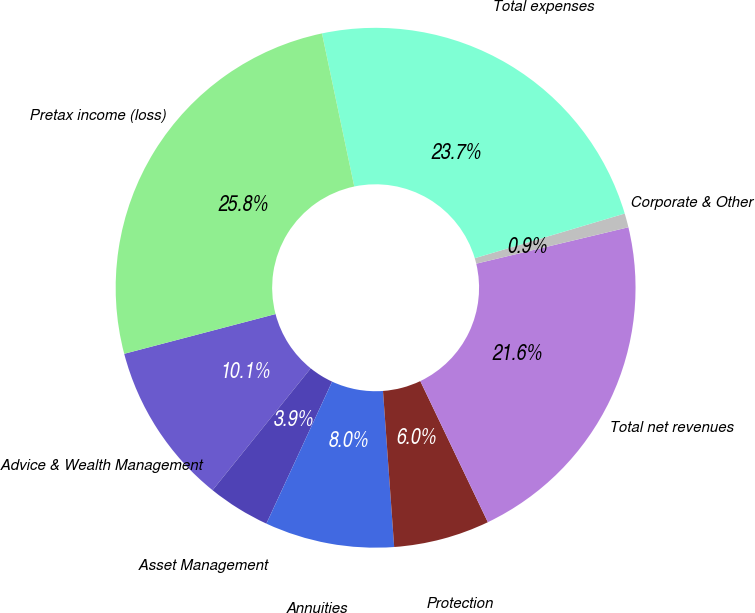Convert chart. <chart><loc_0><loc_0><loc_500><loc_500><pie_chart><fcel>Advice & Wealth Management<fcel>Asset Management<fcel>Annuities<fcel>Protection<fcel>Total net revenues<fcel>Corporate & Other<fcel>Total expenses<fcel>Pretax income (loss)<nl><fcel>10.12%<fcel>3.89%<fcel>8.04%<fcel>5.97%<fcel>21.63%<fcel>0.87%<fcel>23.7%<fcel>25.78%<nl></chart> 